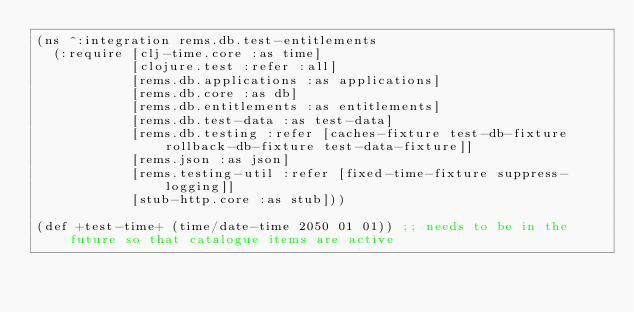<code> <loc_0><loc_0><loc_500><loc_500><_Clojure_>(ns ^:integration rems.db.test-entitlements
  (:require [clj-time.core :as time]
            [clojure.test :refer :all]
            [rems.db.applications :as applications]
            [rems.db.core :as db]
            [rems.db.entitlements :as entitlements]
            [rems.db.test-data :as test-data]
            [rems.db.testing :refer [caches-fixture test-db-fixture rollback-db-fixture test-data-fixture]]
            [rems.json :as json]
            [rems.testing-util :refer [fixed-time-fixture suppress-logging]]
            [stub-http.core :as stub]))

(def +test-time+ (time/date-time 2050 01 01)) ;; needs to be in the future so that catalogue items are active</code> 